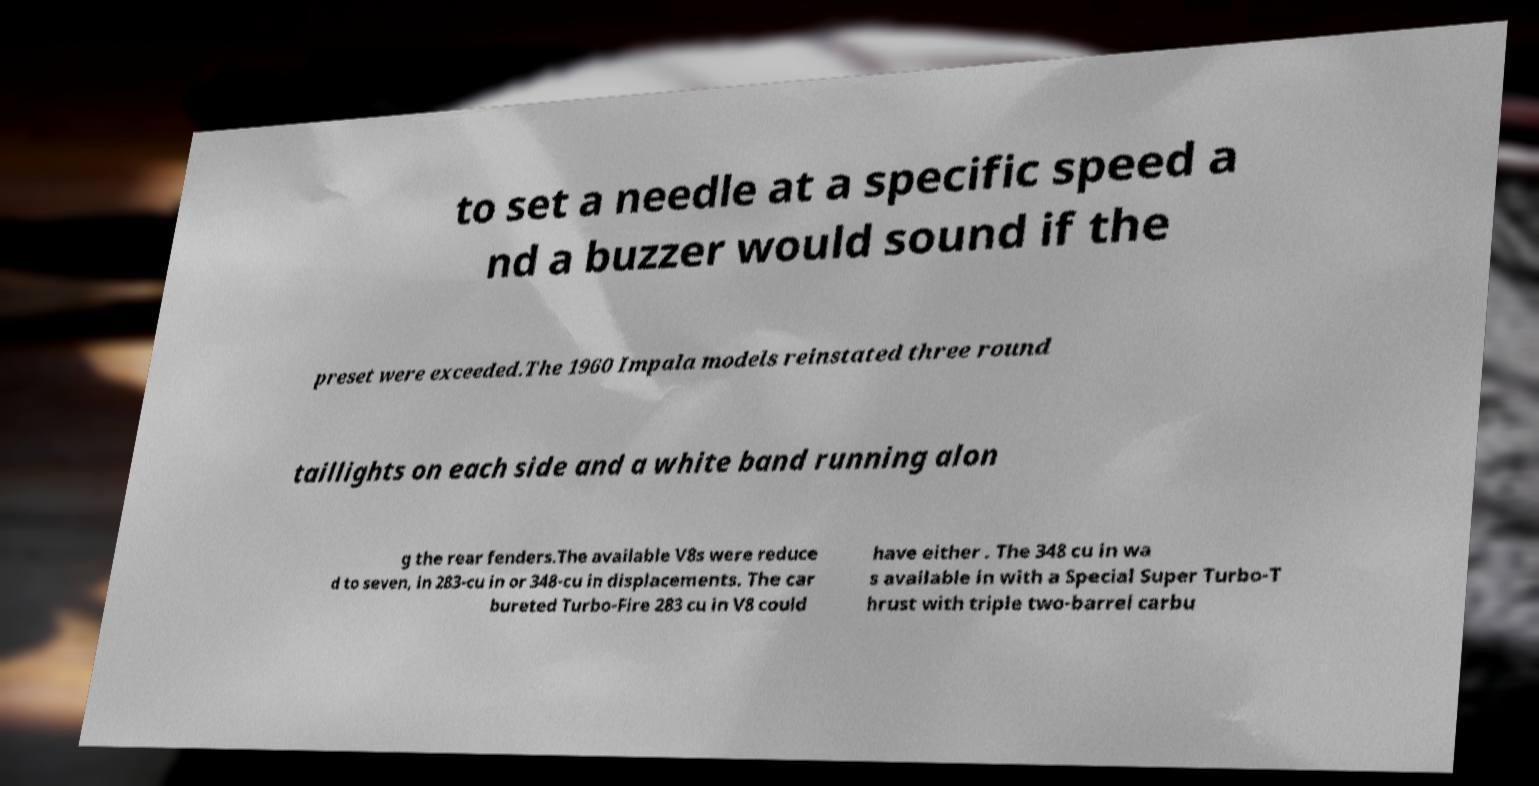Can you accurately transcribe the text from the provided image for me? to set a needle at a specific speed a nd a buzzer would sound if the preset were exceeded.The 1960 Impala models reinstated three round taillights on each side and a white band running alon g the rear fenders.The available V8s were reduce d to seven, in 283-cu in or 348-cu in displacements. The car bureted Turbo-Fire 283 cu in V8 could have either . The 348 cu in wa s available in with a Special Super Turbo-T hrust with triple two-barrel carbu 